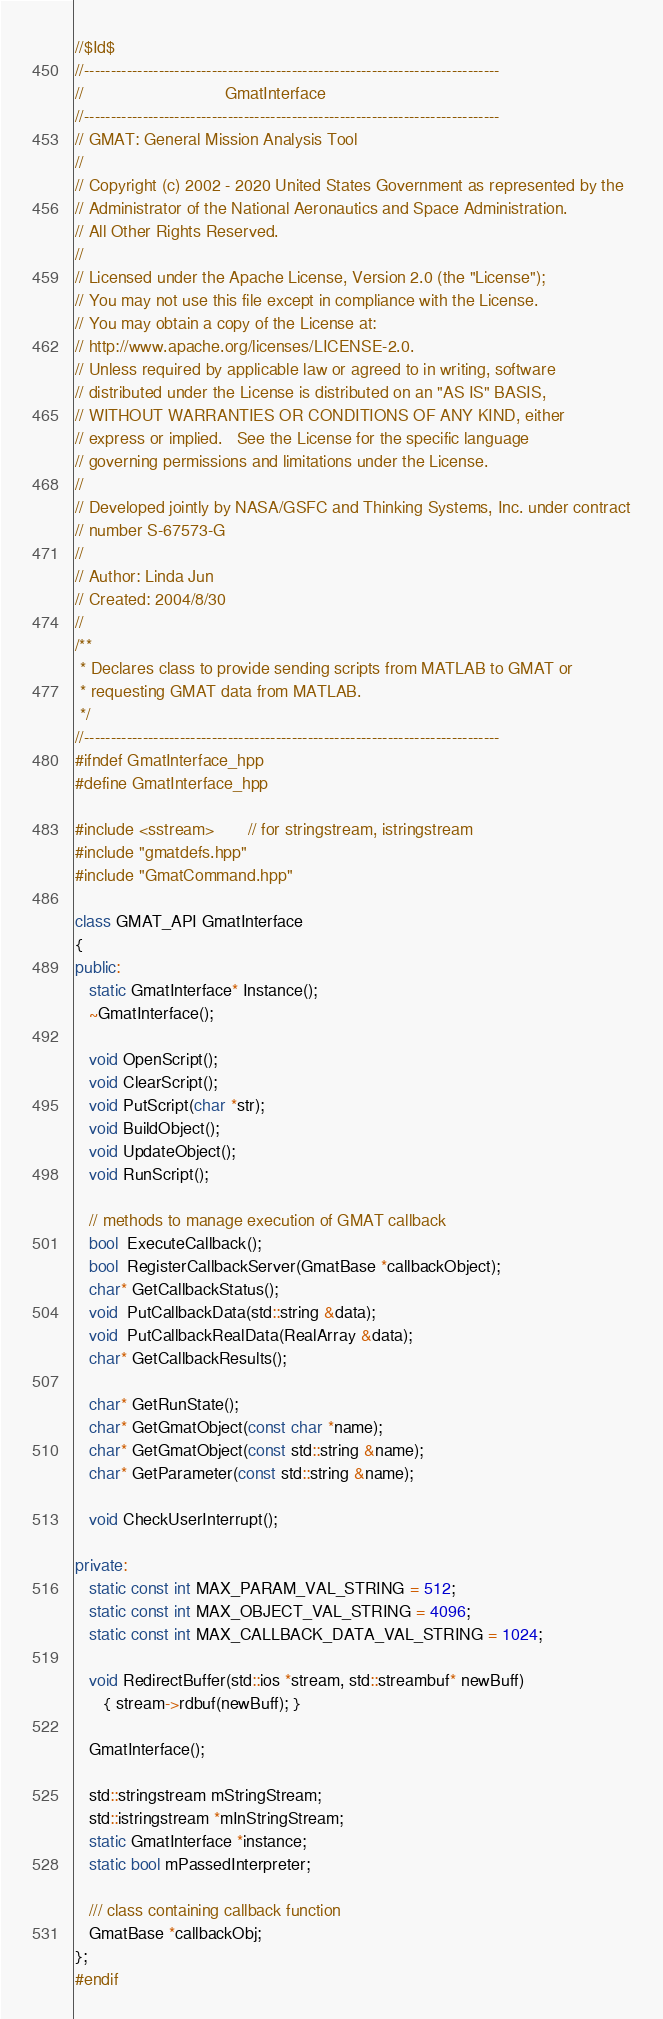<code> <loc_0><loc_0><loc_500><loc_500><_C++_>//$Id$
//------------------------------------------------------------------------------
//                              GmatInterface
//------------------------------------------------------------------------------
// GMAT: General Mission Analysis Tool
//
// Copyright (c) 2002 - 2020 United States Government as represented by the
// Administrator of the National Aeronautics and Space Administration.
// All Other Rights Reserved.
//
// Licensed under the Apache License, Version 2.0 (the "License"); 
// You may not use this file except in compliance with the License. 
// You may obtain a copy of the License at:
// http://www.apache.org/licenses/LICENSE-2.0. 
// Unless required by applicable law or agreed to in writing, software
// distributed under the License is distributed on an "AS IS" BASIS,
// WITHOUT WARRANTIES OR CONDITIONS OF ANY KIND, either 
// express or implied.   See the License for the specific language
// governing permissions and limitations under the License.
//
// Developed jointly by NASA/GSFC and Thinking Systems, Inc. under contract
// number S-67573-G
//
// Author: Linda Jun
// Created: 2004/8/30
//
/**
 * Declares class to provide sending scripts from MATLAB to GMAT or
 * requesting GMAT data from MATLAB.
 */
//------------------------------------------------------------------------------
#ifndef GmatInterface_hpp
#define GmatInterface_hpp

#include <sstream>       // for stringstream, istringstream
#include "gmatdefs.hpp"
#include "GmatCommand.hpp"

class GMAT_API GmatInterface
{
public:
   static GmatInterface* Instance();
   ~GmatInterface();
   
   void OpenScript();
   void ClearScript();
   void PutScript(char *str);
   void BuildObject();
   void UpdateObject();
   void RunScript();
   
   // methods to manage execution of GMAT callback
   bool  ExecuteCallback();
   bool  RegisterCallbackServer(GmatBase *callbackObject);
   char* GetCallbackStatus();
   void  PutCallbackData(std::string &data);
   void  PutCallbackRealData(RealArray &data);
   char* GetCallbackResults();
   
   char* GetRunState();
   char* GetGmatObject(const char *name);
   char* GetGmatObject(const std::string &name);
   char* GetParameter(const std::string &name);
   
   void CheckUserInterrupt();
   
private:
   static const int MAX_PARAM_VAL_STRING = 512;
   static const int MAX_OBJECT_VAL_STRING = 4096;
   static const int MAX_CALLBACK_DATA_VAL_STRING = 1024;
   
   void RedirectBuffer(std::ios *stream, std::streambuf* newBuff) 
      { stream->rdbuf(newBuff); }
   
   GmatInterface();
   
   std::stringstream mStringStream;
   std::istringstream *mInStringStream;
   static GmatInterface *instance;
   static bool mPassedInterpreter;
   
   /// class containing callback function
   GmatBase *callbackObj;  
};
#endif
</code> 